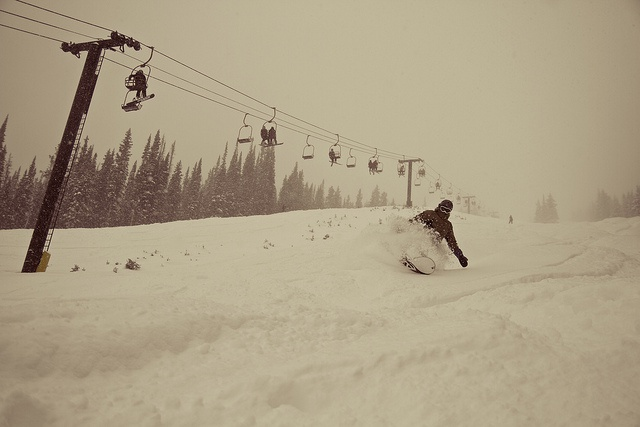Describe the objects in this image and their specific colors. I can see people in gray, tan, black, and maroon tones, snowboard in gray, tan, and black tones, people in gray, black, maroon, and tan tones, people in gray, maroon, and tan tones, and people in gray and maroon tones in this image. 